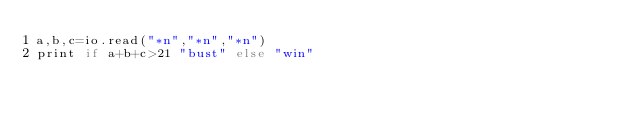Convert code to text. <code><loc_0><loc_0><loc_500><loc_500><_MoonScript_>a,b,c=io.read("*n","*n","*n")
print if a+b+c>21 "bust" else "win"</code> 